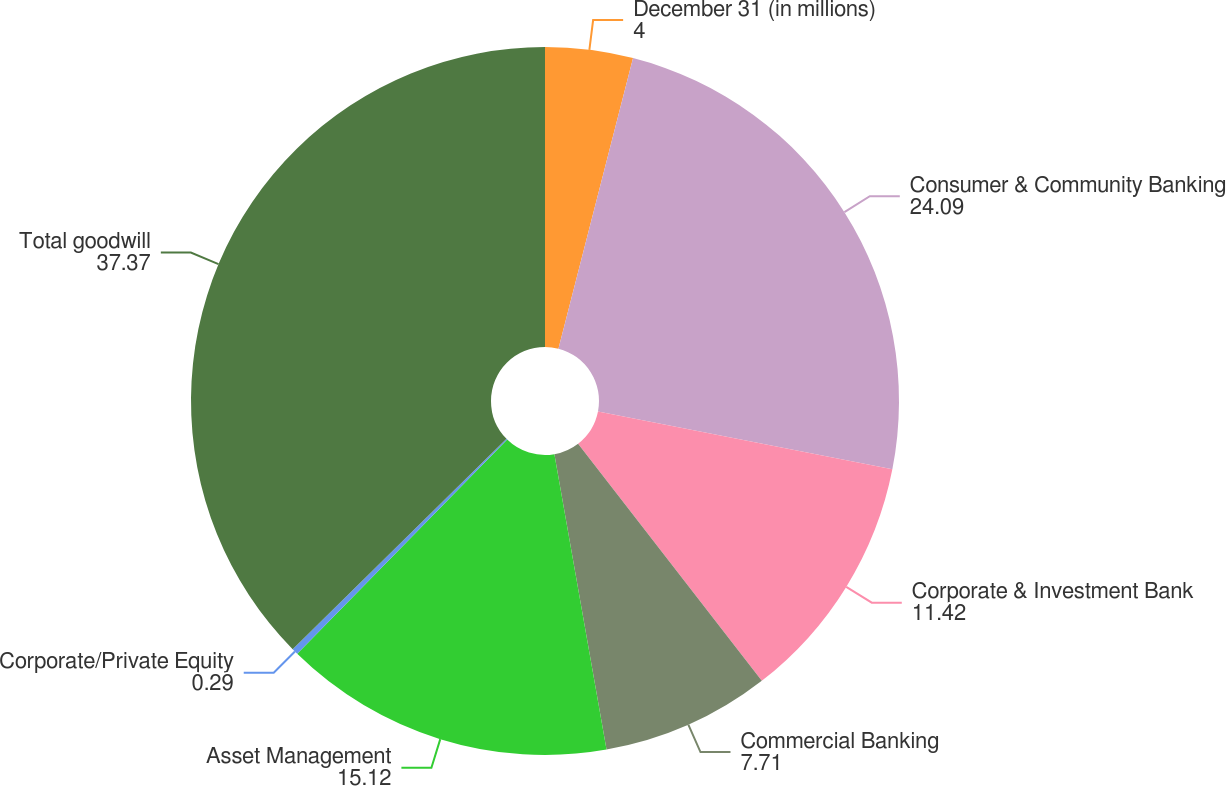Convert chart to OTSL. <chart><loc_0><loc_0><loc_500><loc_500><pie_chart><fcel>December 31 (in millions)<fcel>Consumer & Community Banking<fcel>Corporate & Investment Bank<fcel>Commercial Banking<fcel>Asset Management<fcel>Corporate/Private Equity<fcel>Total goodwill<nl><fcel>4.0%<fcel>24.09%<fcel>11.42%<fcel>7.71%<fcel>15.12%<fcel>0.29%<fcel>37.37%<nl></chart> 